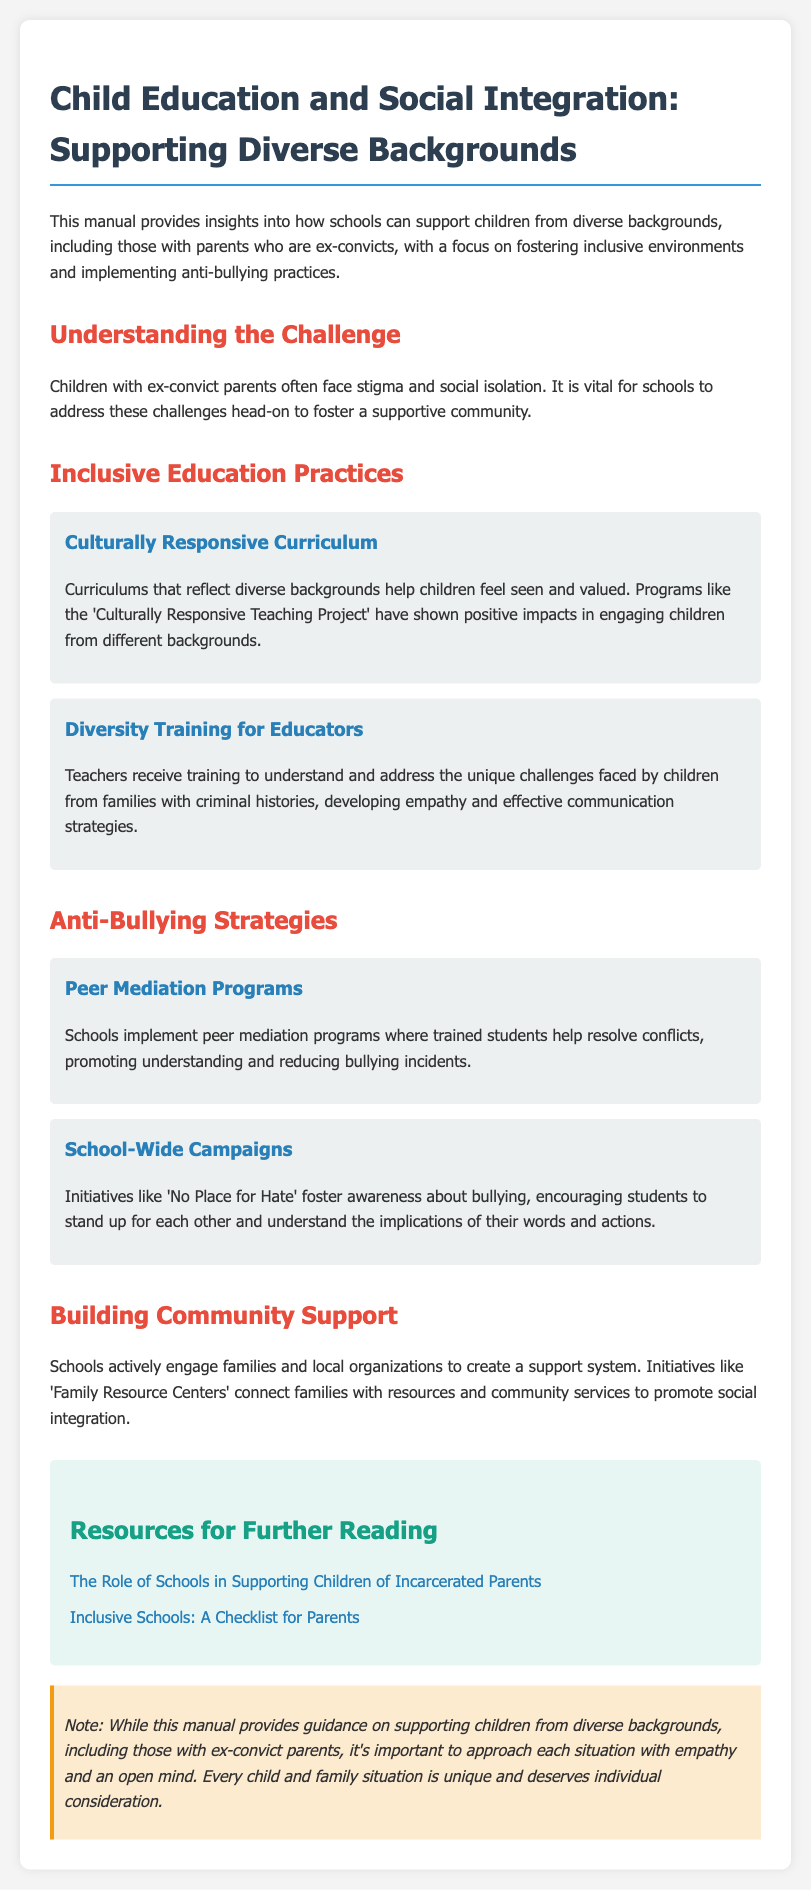What is the title of the manual? The title of the manual is located in the header, providing the overarching theme of the content.
Answer: Child Education and Social Integration: Supporting Diverse Backgrounds What program is mentioned as having a positive impact in engaging children from different backgrounds? The manual references a specific program that reflects diverse backgrounds, illustrating effective practices in education.
Answer: Culturally Responsive Teaching Project What do peer mediation programs aim to promote? The purpose of peer mediation programs is detailed in the document, outlining their role in addressing conflicts among students.
Answer: Understanding What initiative is highlighted for fostering awareness about bullying? An example of a campaign designed to raise awareness about bullying is provided, showing proactive school efforts.
Answer: No Place for Hate What resource is offered for further reading related to supporting children of incarcerated parents? A specific external publication is mentioned in the resources section for those seeking additional information.
Answer: The Role of Schools in Supporting Children of Incarcerated Parents What is a key note emphasized in the manual regarding individual situations? The manual concludes with an important note about the unique nature of each child's situation and the approach needed.
Answer: Empathy and an open mind 